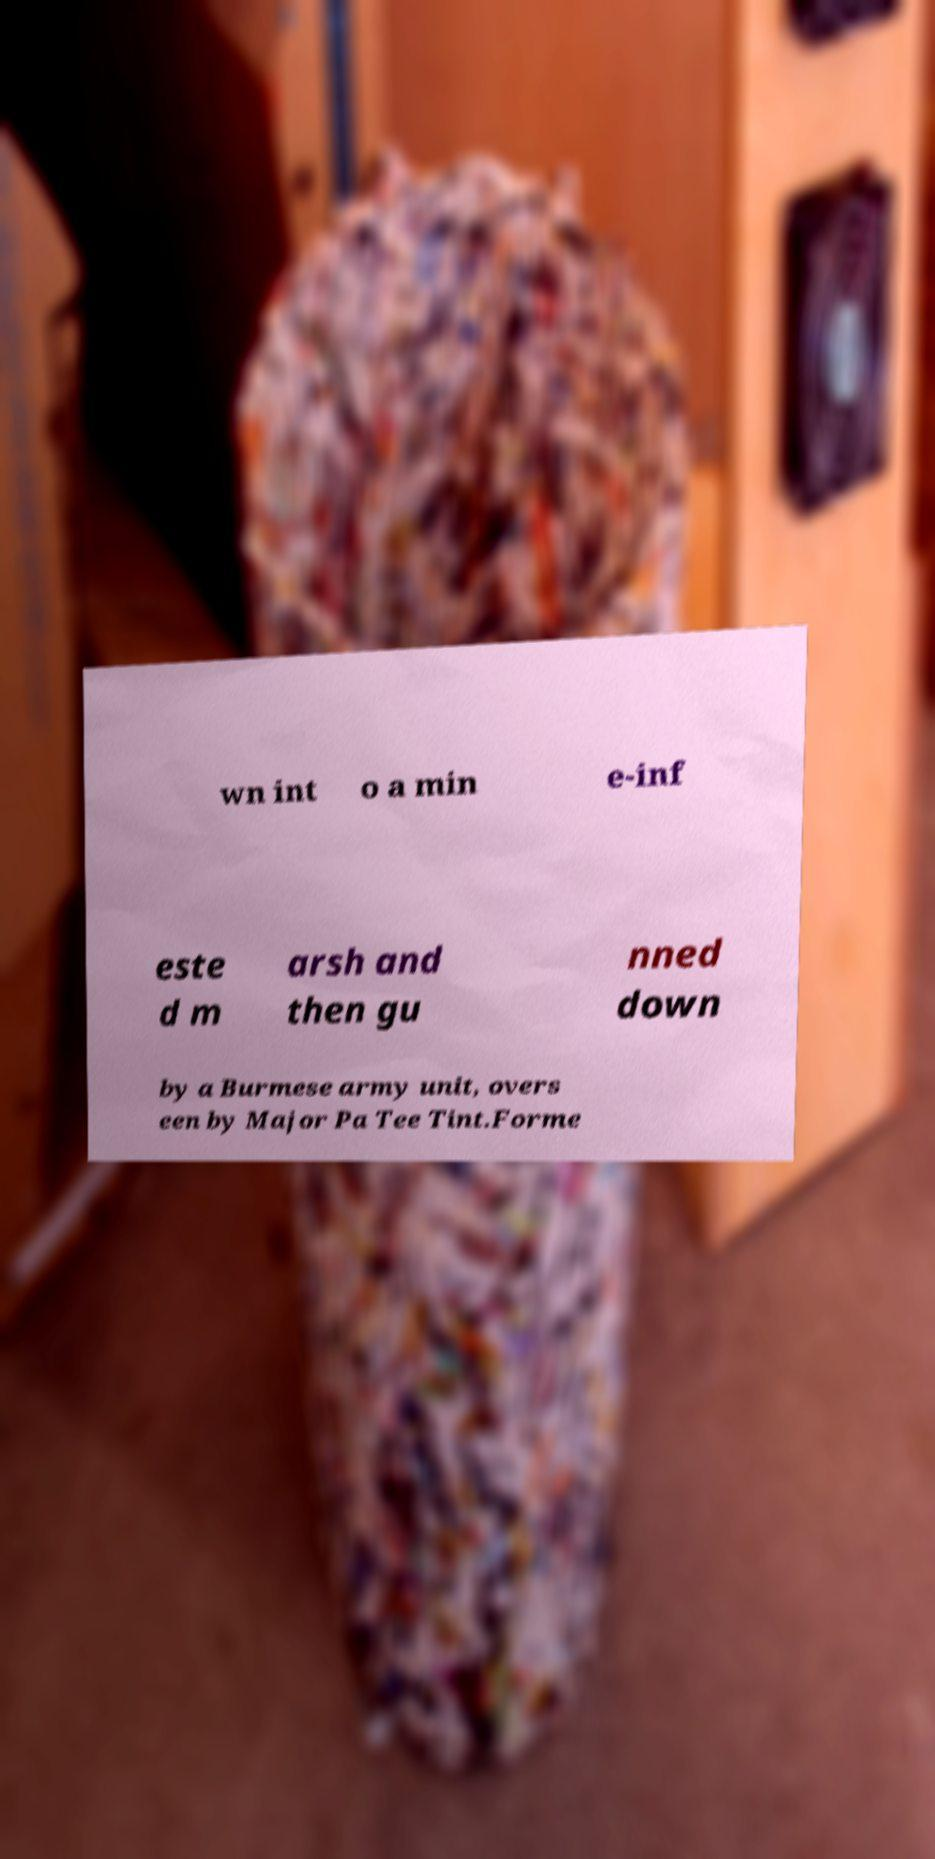I need the written content from this picture converted into text. Can you do that? wn int o a min e-inf este d m arsh and then gu nned down by a Burmese army unit, overs een by Major Pa Tee Tint.Forme 